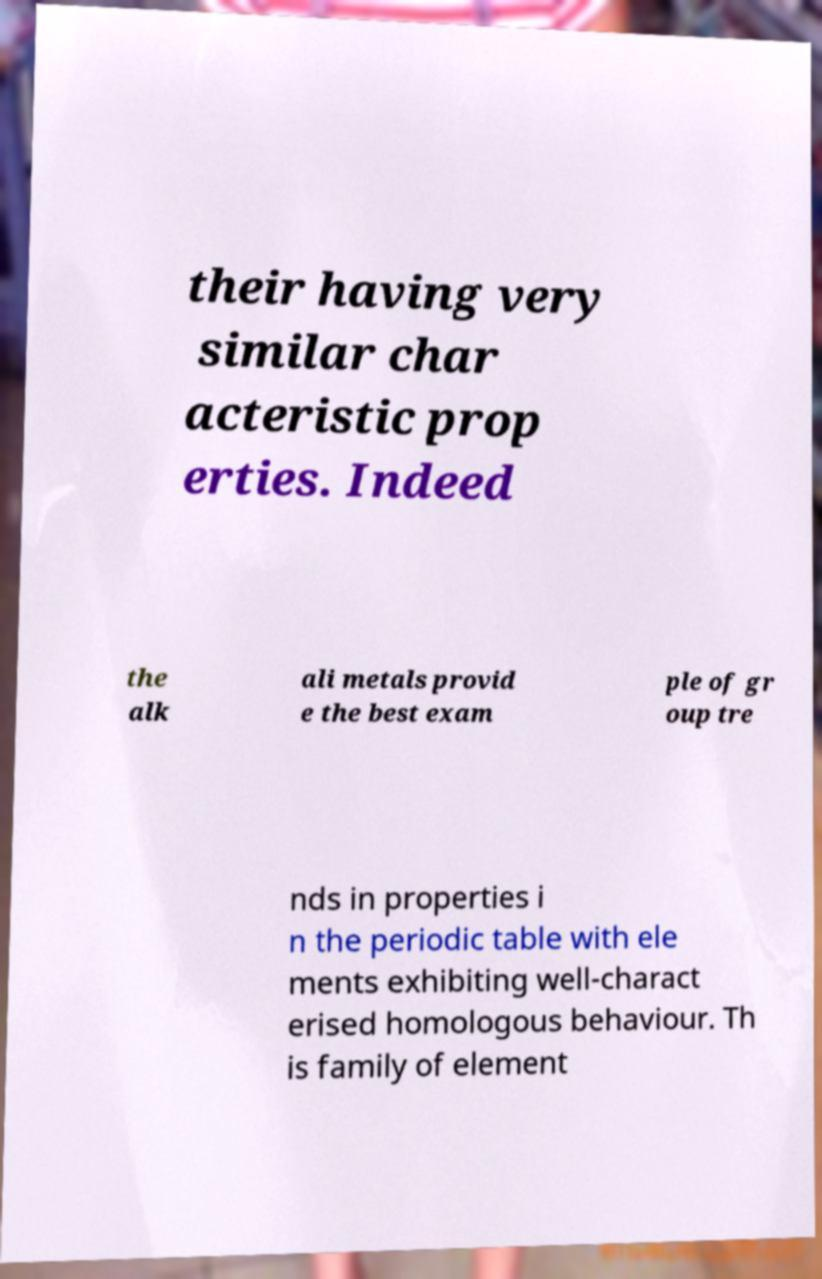Can you accurately transcribe the text from the provided image for me? their having very similar char acteristic prop erties. Indeed the alk ali metals provid e the best exam ple of gr oup tre nds in properties i n the periodic table with ele ments exhibiting well-charact erised homologous behaviour. Th is family of element 